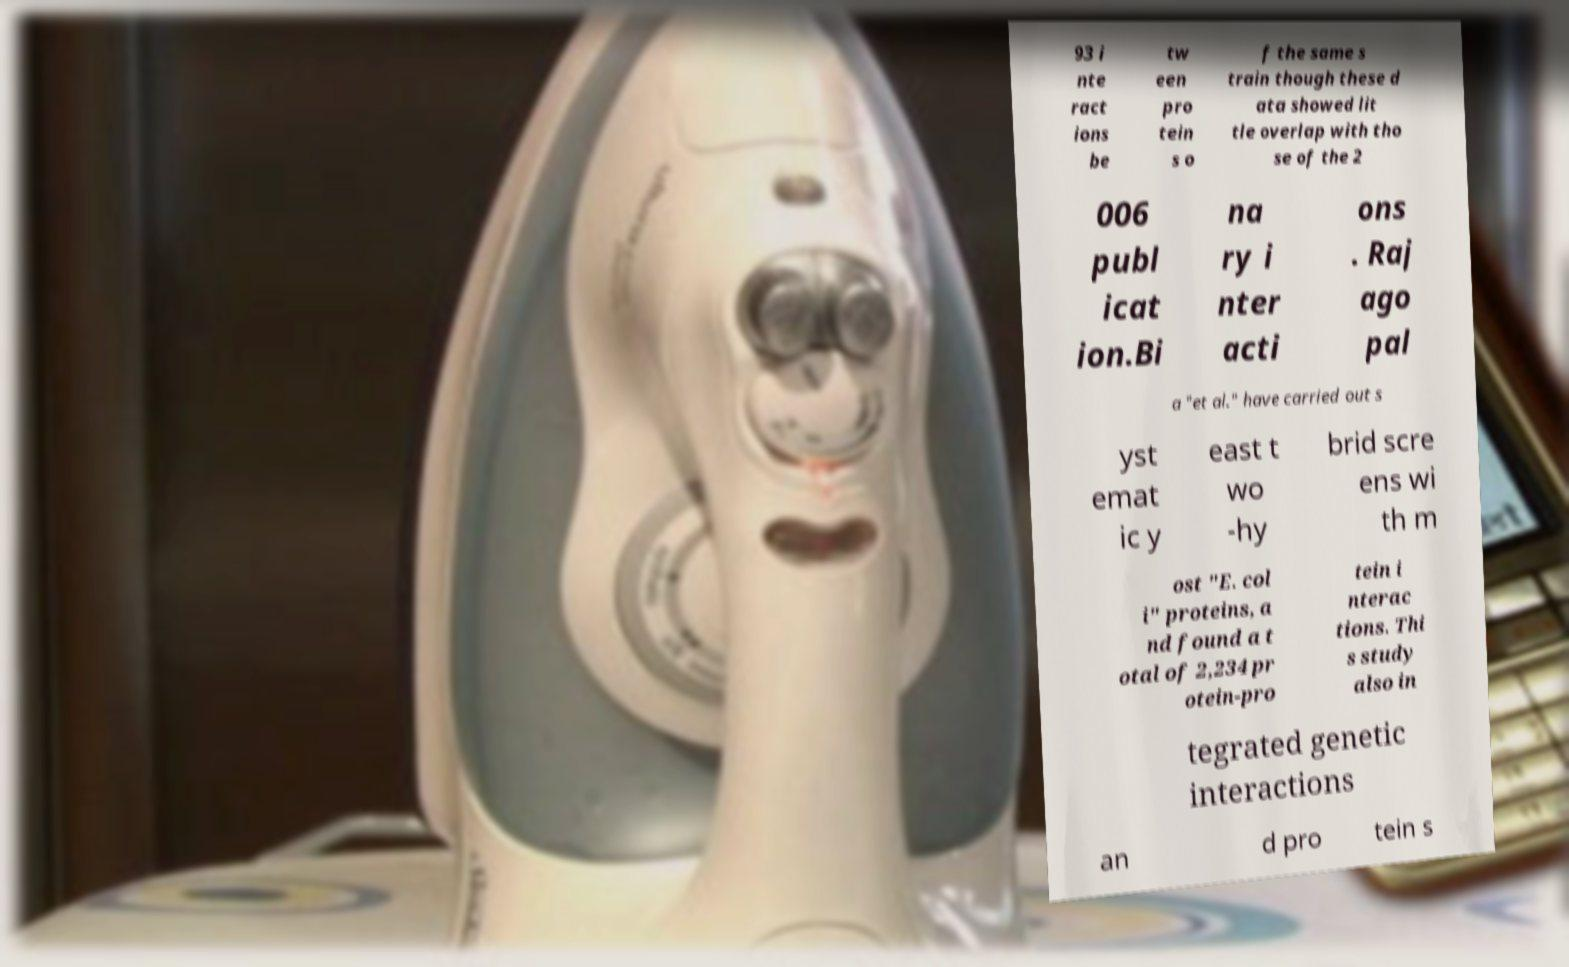For documentation purposes, I need the text within this image transcribed. Could you provide that? 93 i nte ract ions be tw een pro tein s o f the same s train though these d ata showed lit tle overlap with tho se of the 2 006 publ icat ion.Bi na ry i nter acti ons . Raj ago pal a "et al." have carried out s yst emat ic y east t wo -hy brid scre ens wi th m ost "E. col i" proteins, a nd found a t otal of 2,234 pr otein-pro tein i nterac tions. Thi s study also in tegrated genetic interactions an d pro tein s 